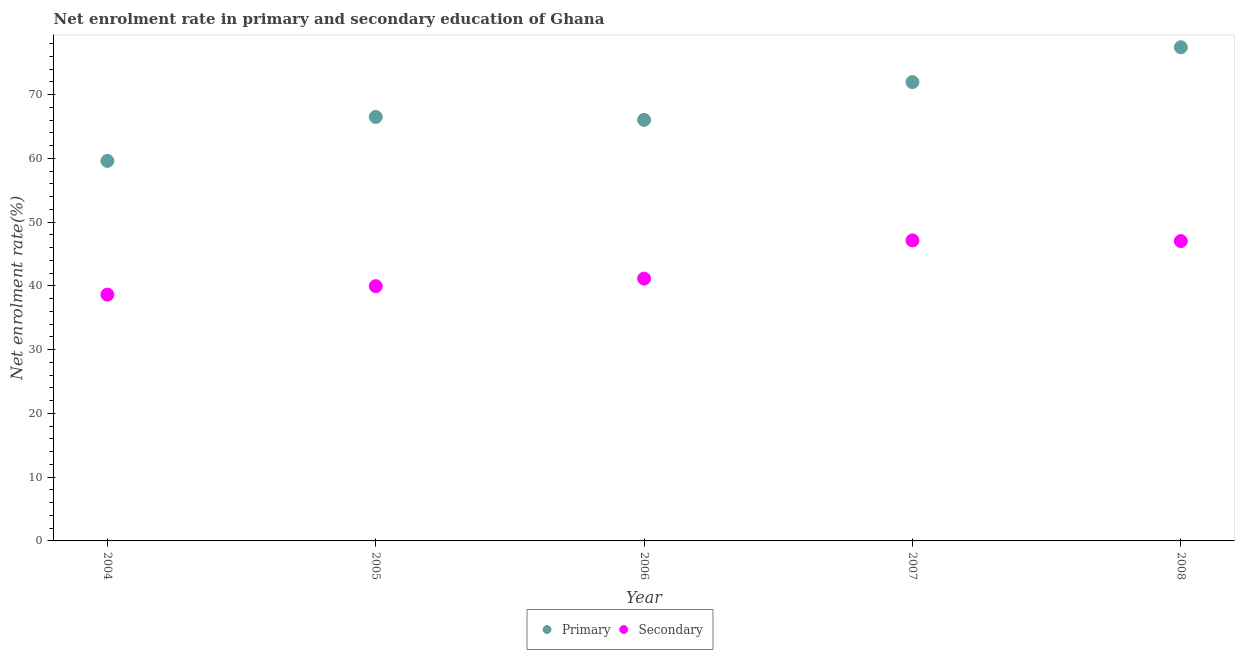How many different coloured dotlines are there?
Provide a succinct answer. 2. What is the enrollment rate in secondary education in 2006?
Offer a very short reply. 41.16. Across all years, what is the maximum enrollment rate in primary education?
Provide a short and direct response. 77.45. Across all years, what is the minimum enrollment rate in primary education?
Provide a succinct answer. 59.62. What is the total enrollment rate in primary education in the graph?
Give a very brief answer. 341.62. What is the difference between the enrollment rate in primary education in 2006 and that in 2007?
Ensure brevity in your answer.  -5.93. What is the difference between the enrollment rate in primary education in 2007 and the enrollment rate in secondary education in 2005?
Offer a very short reply. 32.02. What is the average enrollment rate in secondary education per year?
Your response must be concise. 42.79. In the year 2007, what is the difference between the enrollment rate in secondary education and enrollment rate in primary education?
Provide a succinct answer. -24.84. What is the ratio of the enrollment rate in secondary education in 2007 to that in 2008?
Ensure brevity in your answer.  1. Is the difference between the enrollment rate in primary education in 2005 and 2006 greater than the difference between the enrollment rate in secondary education in 2005 and 2006?
Your answer should be very brief. Yes. What is the difference between the highest and the second highest enrollment rate in secondary education?
Offer a very short reply. 0.11. What is the difference between the highest and the lowest enrollment rate in secondary education?
Keep it short and to the point. 8.5. Is the sum of the enrollment rate in primary education in 2004 and 2005 greater than the maximum enrollment rate in secondary education across all years?
Keep it short and to the point. Yes. Does the enrollment rate in secondary education monotonically increase over the years?
Ensure brevity in your answer.  No. Is the enrollment rate in primary education strictly greater than the enrollment rate in secondary education over the years?
Your answer should be very brief. Yes. How many dotlines are there?
Keep it short and to the point. 2. Does the graph contain any zero values?
Provide a succinct answer. No. Where does the legend appear in the graph?
Your answer should be compact. Bottom center. How are the legend labels stacked?
Make the answer very short. Horizontal. What is the title of the graph?
Offer a terse response. Net enrolment rate in primary and secondary education of Ghana. Does "By country of asylum" appear as one of the legend labels in the graph?
Give a very brief answer. No. What is the label or title of the Y-axis?
Provide a succinct answer. Net enrolment rate(%). What is the Net enrolment rate(%) in Primary in 2004?
Offer a very short reply. 59.62. What is the Net enrolment rate(%) in Secondary in 2004?
Your answer should be very brief. 38.65. What is the Net enrolment rate(%) in Primary in 2005?
Your response must be concise. 66.51. What is the Net enrolment rate(%) of Secondary in 2005?
Your response must be concise. 39.97. What is the Net enrolment rate(%) in Primary in 2006?
Make the answer very short. 66.06. What is the Net enrolment rate(%) in Secondary in 2006?
Offer a very short reply. 41.16. What is the Net enrolment rate(%) of Primary in 2007?
Keep it short and to the point. 71.98. What is the Net enrolment rate(%) of Secondary in 2007?
Make the answer very short. 47.15. What is the Net enrolment rate(%) of Primary in 2008?
Offer a very short reply. 77.45. What is the Net enrolment rate(%) in Secondary in 2008?
Provide a short and direct response. 47.04. Across all years, what is the maximum Net enrolment rate(%) in Primary?
Offer a terse response. 77.45. Across all years, what is the maximum Net enrolment rate(%) of Secondary?
Provide a succinct answer. 47.15. Across all years, what is the minimum Net enrolment rate(%) of Primary?
Your response must be concise. 59.62. Across all years, what is the minimum Net enrolment rate(%) in Secondary?
Keep it short and to the point. 38.65. What is the total Net enrolment rate(%) in Primary in the graph?
Provide a succinct answer. 341.62. What is the total Net enrolment rate(%) in Secondary in the graph?
Make the answer very short. 213.96. What is the difference between the Net enrolment rate(%) of Primary in 2004 and that in 2005?
Keep it short and to the point. -6.9. What is the difference between the Net enrolment rate(%) of Secondary in 2004 and that in 2005?
Your answer should be compact. -1.32. What is the difference between the Net enrolment rate(%) in Primary in 2004 and that in 2006?
Your answer should be compact. -6.44. What is the difference between the Net enrolment rate(%) of Secondary in 2004 and that in 2006?
Your answer should be very brief. -2.51. What is the difference between the Net enrolment rate(%) in Primary in 2004 and that in 2007?
Keep it short and to the point. -12.37. What is the difference between the Net enrolment rate(%) in Secondary in 2004 and that in 2007?
Provide a succinct answer. -8.5. What is the difference between the Net enrolment rate(%) in Primary in 2004 and that in 2008?
Provide a short and direct response. -17.83. What is the difference between the Net enrolment rate(%) of Secondary in 2004 and that in 2008?
Give a very brief answer. -8.39. What is the difference between the Net enrolment rate(%) in Primary in 2005 and that in 2006?
Make the answer very short. 0.46. What is the difference between the Net enrolment rate(%) of Secondary in 2005 and that in 2006?
Provide a succinct answer. -1.19. What is the difference between the Net enrolment rate(%) of Primary in 2005 and that in 2007?
Your answer should be compact. -5.47. What is the difference between the Net enrolment rate(%) in Secondary in 2005 and that in 2007?
Your answer should be very brief. -7.18. What is the difference between the Net enrolment rate(%) in Primary in 2005 and that in 2008?
Your answer should be very brief. -10.94. What is the difference between the Net enrolment rate(%) of Secondary in 2005 and that in 2008?
Provide a succinct answer. -7.07. What is the difference between the Net enrolment rate(%) in Primary in 2006 and that in 2007?
Make the answer very short. -5.93. What is the difference between the Net enrolment rate(%) of Secondary in 2006 and that in 2007?
Offer a terse response. -5.99. What is the difference between the Net enrolment rate(%) in Primary in 2006 and that in 2008?
Offer a very short reply. -11.39. What is the difference between the Net enrolment rate(%) of Secondary in 2006 and that in 2008?
Provide a succinct answer. -5.88. What is the difference between the Net enrolment rate(%) in Primary in 2007 and that in 2008?
Offer a terse response. -5.47. What is the difference between the Net enrolment rate(%) in Secondary in 2007 and that in 2008?
Your response must be concise. 0.11. What is the difference between the Net enrolment rate(%) in Primary in 2004 and the Net enrolment rate(%) in Secondary in 2005?
Keep it short and to the point. 19.65. What is the difference between the Net enrolment rate(%) in Primary in 2004 and the Net enrolment rate(%) in Secondary in 2006?
Your answer should be very brief. 18.46. What is the difference between the Net enrolment rate(%) of Primary in 2004 and the Net enrolment rate(%) of Secondary in 2007?
Your response must be concise. 12.47. What is the difference between the Net enrolment rate(%) in Primary in 2004 and the Net enrolment rate(%) in Secondary in 2008?
Your answer should be very brief. 12.58. What is the difference between the Net enrolment rate(%) of Primary in 2005 and the Net enrolment rate(%) of Secondary in 2006?
Provide a short and direct response. 25.36. What is the difference between the Net enrolment rate(%) in Primary in 2005 and the Net enrolment rate(%) in Secondary in 2007?
Make the answer very short. 19.37. What is the difference between the Net enrolment rate(%) in Primary in 2005 and the Net enrolment rate(%) in Secondary in 2008?
Provide a succinct answer. 19.47. What is the difference between the Net enrolment rate(%) of Primary in 2006 and the Net enrolment rate(%) of Secondary in 2007?
Make the answer very short. 18.91. What is the difference between the Net enrolment rate(%) in Primary in 2006 and the Net enrolment rate(%) in Secondary in 2008?
Ensure brevity in your answer.  19.02. What is the difference between the Net enrolment rate(%) of Primary in 2007 and the Net enrolment rate(%) of Secondary in 2008?
Keep it short and to the point. 24.94. What is the average Net enrolment rate(%) in Primary per year?
Keep it short and to the point. 68.32. What is the average Net enrolment rate(%) in Secondary per year?
Provide a succinct answer. 42.79. In the year 2004, what is the difference between the Net enrolment rate(%) in Primary and Net enrolment rate(%) in Secondary?
Offer a terse response. 20.97. In the year 2005, what is the difference between the Net enrolment rate(%) of Primary and Net enrolment rate(%) of Secondary?
Offer a terse response. 26.55. In the year 2006, what is the difference between the Net enrolment rate(%) of Primary and Net enrolment rate(%) of Secondary?
Give a very brief answer. 24.9. In the year 2007, what is the difference between the Net enrolment rate(%) of Primary and Net enrolment rate(%) of Secondary?
Make the answer very short. 24.84. In the year 2008, what is the difference between the Net enrolment rate(%) in Primary and Net enrolment rate(%) in Secondary?
Make the answer very short. 30.41. What is the ratio of the Net enrolment rate(%) in Primary in 2004 to that in 2005?
Your response must be concise. 0.9. What is the ratio of the Net enrolment rate(%) of Secondary in 2004 to that in 2005?
Provide a short and direct response. 0.97. What is the ratio of the Net enrolment rate(%) of Primary in 2004 to that in 2006?
Ensure brevity in your answer.  0.9. What is the ratio of the Net enrolment rate(%) of Secondary in 2004 to that in 2006?
Keep it short and to the point. 0.94. What is the ratio of the Net enrolment rate(%) in Primary in 2004 to that in 2007?
Your response must be concise. 0.83. What is the ratio of the Net enrolment rate(%) in Secondary in 2004 to that in 2007?
Your response must be concise. 0.82. What is the ratio of the Net enrolment rate(%) in Primary in 2004 to that in 2008?
Your answer should be very brief. 0.77. What is the ratio of the Net enrolment rate(%) of Secondary in 2004 to that in 2008?
Your response must be concise. 0.82. What is the ratio of the Net enrolment rate(%) of Primary in 2005 to that in 2006?
Offer a terse response. 1.01. What is the ratio of the Net enrolment rate(%) of Secondary in 2005 to that in 2006?
Ensure brevity in your answer.  0.97. What is the ratio of the Net enrolment rate(%) in Primary in 2005 to that in 2007?
Offer a terse response. 0.92. What is the ratio of the Net enrolment rate(%) in Secondary in 2005 to that in 2007?
Your response must be concise. 0.85. What is the ratio of the Net enrolment rate(%) of Primary in 2005 to that in 2008?
Your answer should be compact. 0.86. What is the ratio of the Net enrolment rate(%) of Secondary in 2005 to that in 2008?
Offer a very short reply. 0.85. What is the ratio of the Net enrolment rate(%) in Primary in 2006 to that in 2007?
Give a very brief answer. 0.92. What is the ratio of the Net enrolment rate(%) in Secondary in 2006 to that in 2007?
Give a very brief answer. 0.87. What is the ratio of the Net enrolment rate(%) in Primary in 2006 to that in 2008?
Offer a very short reply. 0.85. What is the ratio of the Net enrolment rate(%) of Secondary in 2006 to that in 2008?
Provide a succinct answer. 0.87. What is the ratio of the Net enrolment rate(%) of Primary in 2007 to that in 2008?
Provide a succinct answer. 0.93. What is the difference between the highest and the second highest Net enrolment rate(%) in Primary?
Keep it short and to the point. 5.47. What is the difference between the highest and the second highest Net enrolment rate(%) of Secondary?
Make the answer very short. 0.11. What is the difference between the highest and the lowest Net enrolment rate(%) in Primary?
Ensure brevity in your answer.  17.83. What is the difference between the highest and the lowest Net enrolment rate(%) in Secondary?
Provide a succinct answer. 8.5. 